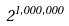Convert formula to latex. <formula><loc_0><loc_0><loc_500><loc_500>2 ^ { 1 , 0 0 0 , 0 0 0 }</formula> 